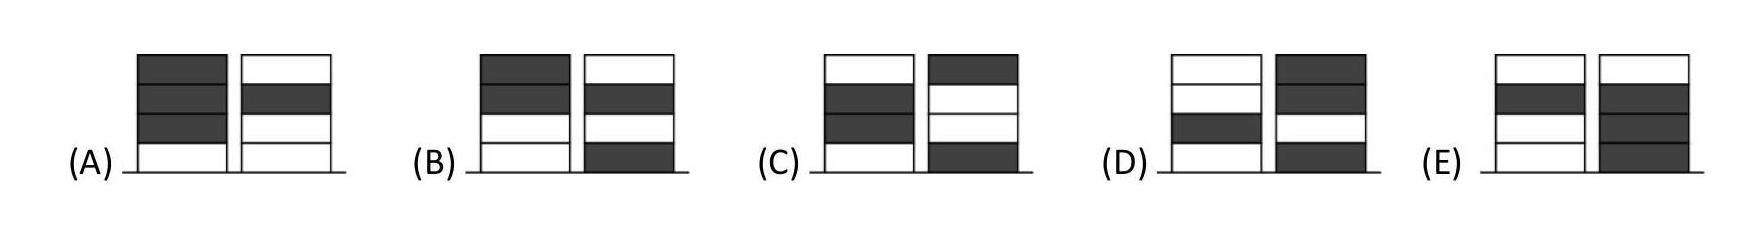What is the maximum number of tokens that can be placed in a single pile without repeating a color? Considering each has four tokens of a unique color, the maximum number in a pile without repeating the same color would be one of each, totaling two tokens. 